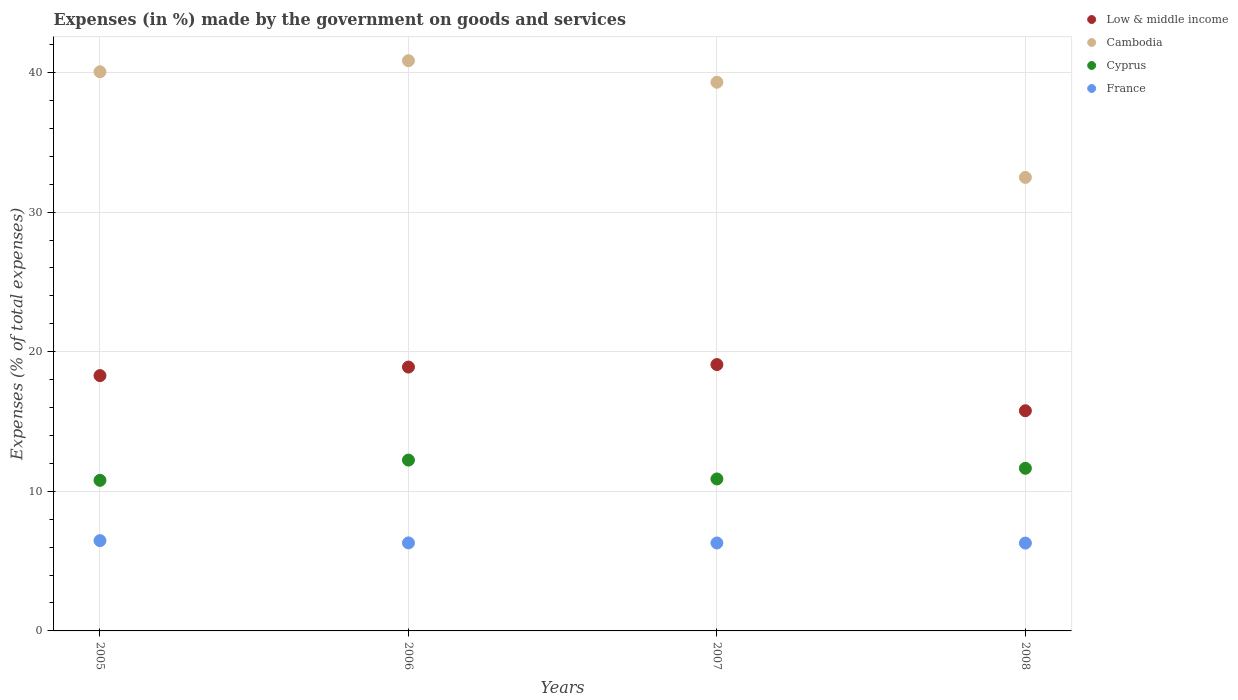How many different coloured dotlines are there?
Offer a very short reply. 4. What is the percentage of expenses made by the government on goods and services in Low & middle income in 2008?
Offer a very short reply. 15.77. Across all years, what is the maximum percentage of expenses made by the government on goods and services in France?
Ensure brevity in your answer.  6.47. Across all years, what is the minimum percentage of expenses made by the government on goods and services in Low & middle income?
Ensure brevity in your answer.  15.77. In which year was the percentage of expenses made by the government on goods and services in Cambodia maximum?
Offer a terse response. 2006. What is the total percentage of expenses made by the government on goods and services in Cambodia in the graph?
Ensure brevity in your answer.  152.67. What is the difference between the percentage of expenses made by the government on goods and services in France in 2005 and that in 2008?
Offer a terse response. 0.17. What is the difference between the percentage of expenses made by the government on goods and services in Low & middle income in 2006 and the percentage of expenses made by the government on goods and services in Cambodia in 2007?
Your answer should be very brief. -20.4. What is the average percentage of expenses made by the government on goods and services in Low & middle income per year?
Ensure brevity in your answer.  18.01. In the year 2007, what is the difference between the percentage of expenses made by the government on goods and services in Cyprus and percentage of expenses made by the government on goods and services in France?
Offer a terse response. 4.59. What is the ratio of the percentage of expenses made by the government on goods and services in France in 2005 to that in 2006?
Provide a succinct answer. 1.03. Is the percentage of expenses made by the government on goods and services in France in 2007 less than that in 2008?
Offer a very short reply. No. What is the difference between the highest and the second highest percentage of expenses made by the government on goods and services in Cyprus?
Provide a succinct answer. 0.59. What is the difference between the highest and the lowest percentage of expenses made by the government on goods and services in Cambodia?
Ensure brevity in your answer.  8.36. Is it the case that in every year, the sum of the percentage of expenses made by the government on goods and services in France and percentage of expenses made by the government on goods and services in Cambodia  is greater than the percentage of expenses made by the government on goods and services in Low & middle income?
Give a very brief answer. Yes. Are the values on the major ticks of Y-axis written in scientific E-notation?
Your answer should be very brief. No. Where does the legend appear in the graph?
Ensure brevity in your answer.  Top right. How many legend labels are there?
Offer a very short reply. 4. What is the title of the graph?
Provide a short and direct response. Expenses (in %) made by the government on goods and services. Does "Moldova" appear as one of the legend labels in the graph?
Offer a terse response. No. What is the label or title of the X-axis?
Your response must be concise. Years. What is the label or title of the Y-axis?
Offer a terse response. Expenses (% of total expenses). What is the Expenses (% of total expenses) in Low & middle income in 2005?
Provide a succinct answer. 18.29. What is the Expenses (% of total expenses) of Cambodia in 2005?
Give a very brief answer. 40.05. What is the Expenses (% of total expenses) in Cyprus in 2005?
Give a very brief answer. 10.79. What is the Expenses (% of total expenses) of France in 2005?
Your answer should be very brief. 6.47. What is the Expenses (% of total expenses) in Low & middle income in 2006?
Keep it short and to the point. 18.9. What is the Expenses (% of total expenses) of Cambodia in 2006?
Offer a very short reply. 40.84. What is the Expenses (% of total expenses) of Cyprus in 2006?
Give a very brief answer. 12.24. What is the Expenses (% of total expenses) in France in 2006?
Your response must be concise. 6.3. What is the Expenses (% of total expenses) of Low & middle income in 2007?
Make the answer very short. 19.08. What is the Expenses (% of total expenses) of Cambodia in 2007?
Offer a very short reply. 39.3. What is the Expenses (% of total expenses) of Cyprus in 2007?
Give a very brief answer. 10.89. What is the Expenses (% of total expenses) in France in 2007?
Offer a terse response. 6.3. What is the Expenses (% of total expenses) of Low & middle income in 2008?
Offer a terse response. 15.77. What is the Expenses (% of total expenses) of Cambodia in 2008?
Provide a short and direct response. 32.48. What is the Expenses (% of total expenses) in Cyprus in 2008?
Your answer should be very brief. 11.65. What is the Expenses (% of total expenses) in France in 2008?
Offer a very short reply. 6.29. Across all years, what is the maximum Expenses (% of total expenses) of Low & middle income?
Provide a succinct answer. 19.08. Across all years, what is the maximum Expenses (% of total expenses) in Cambodia?
Provide a succinct answer. 40.84. Across all years, what is the maximum Expenses (% of total expenses) of Cyprus?
Your answer should be very brief. 12.24. Across all years, what is the maximum Expenses (% of total expenses) of France?
Your answer should be compact. 6.47. Across all years, what is the minimum Expenses (% of total expenses) in Low & middle income?
Your answer should be compact. 15.77. Across all years, what is the minimum Expenses (% of total expenses) in Cambodia?
Your answer should be compact. 32.48. Across all years, what is the minimum Expenses (% of total expenses) in Cyprus?
Your answer should be compact. 10.79. Across all years, what is the minimum Expenses (% of total expenses) of France?
Provide a short and direct response. 6.29. What is the total Expenses (% of total expenses) in Low & middle income in the graph?
Ensure brevity in your answer.  72.04. What is the total Expenses (% of total expenses) in Cambodia in the graph?
Provide a succinct answer. 152.67. What is the total Expenses (% of total expenses) of Cyprus in the graph?
Keep it short and to the point. 45.56. What is the total Expenses (% of total expenses) of France in the graph?
Offer a very short reply. 25.36. What is the difference between the Expenses (% of total expenses) in Low & middle income in 2005 and that in 2006?
Provide a succinct answer. -0.61. What is the difference between the Expenses (% of total expenses) in Cambodia in 2005 and that in 2006?
Your response must be concise. -0.79. What is the difference between the Expenses (% of total expenses) in Cyprus in 2005 and that in 2006?
Ensure brevity in your answer.  -1.45. What is the difference between the Expenses (% of total expenses) of France in 2005 and that in 2006?
Ensure brevity in your answer.  0.16. What is the difference between the Expenses (% of total expenses) of Low & middle income in 2005 and that in 2007?
Offer a terse response. -0.79. What is the difference between the Expenses (% of total expenses) of Cambodia in 2005 and that in 2007?
Provide a short and direct response. 0.75. What is the difference between the Expenses (% of total expenses) of Cyprus in 2005 and that in 2007?
Make the answer very short. -0.1. What is the difference between the Expenses (% of total expenses) of France in 2005 and that in 2007?
Make the answer very short. 0.17. What is the difference between the Expenses (% of total expenses) of Low & middle income in 2005 and that in 2008?
Offer a very short reply. 2.52. What is the difference between the Expenses (% of total expenses) in Cambodia in 2005 and that in 2008?
Offer a very short reply. 7.57. What is the difference between the Expenses (% of total expenses) in Cyprus in 2005 and that in 2008?
Ensure brevity in your answer.  -0.86. What is the difference between the Expenses (% of total expenses) in France in 2005 and that in 2008?
Provide a short and direct response. 0.17. What is the difference between the Expenses (% of total expenses) in Low & middle income in 2006 and that in 2007?
Your response must be concise. -0.18. What is the difference between the Expenses (% of total expenses) of Cambodia in 2006 and that in 2007?
Ensure brevity in your answer.  1.54. What is the difference between the Expenses (% of total expenses) in Cyprus in 2006 and that in 2007?
Your answer should be very brief. 1.35. What is the difference between the Expenses (% of total expenses) in France in 2006 and that in 2007?
Give a very brief answer. 0.01. What is the difference between the Expenses (% of total expenses) of Low & middle income in 2006 and that in 2008?
Your answer should be very brief. 3.13. What is the difference between the Expenses (% of total expenses) of Cambodia in 2006 and that in 2008?
Give a very brief answer. 8.36. What is the difference between the Expenses (% of total expenses) in Cyprus in 2006 and that in 2008?
Provide a succinct answer. 0.59. What is the difference between the Expenses (% of total expenses) of France in 2006 and that in 2008?
Offer a very short reply. 0.01. What is the difference between the Expenses (% of total expenses) in Low & middle income in 2007 and that in 2008?
Your response must be concise. 3.31. What is the difference between the Expenses (% of total expenses) in Cambodia in 2007 and that in 2008?
Offer a very short reply. 6.82. What is the difference between the Expenses (% of total expenses) in Cyprus in 2007 and that in 2008?
Offer a terse response. -0.76. What is the difference between the Expenses (% of total expenses) in France in 2007 and that in 2008?
Ensure brevity in your answer.  0.01. What is the difference between the Expenses (% of total expenses) in Low & middle income in 2005 and the Expenses (% of total expenses) in Cambodia in 2006?
Your response must be concise. -22.56. What is the difference between the Expenses (% of total expenses) of Low & middle income in 2005 and the Expenses (% of total expenses) of Cyprus in 2006?
Make the answer very short. 6.05. What is the difference between the Expenses (% of total expenses) in Low & middle income in 2005 and the Expenses (% of total expenses) in France in 2006?
Provide a short and direct response. 11.98. What is the difference between the Expenses (% of total expenses) in Cambodia in 2005 and the Expenses (% of total expenses) in Cyprus in 2006?
Offer a very short reply. 27.81. What is the difference between the Expenses (% of total expenses) in Cambodia in 2005 and the Expenses (% of total expenses) in France in 2006?
Make the answer very short. 33.74. What is the difference between the Expenses (% of total expenses) of Cyprus in 2005 and the Expenses (% of total expenses) of France in 2006?
Ensure brevity in your answer.  4.48. What is the difference between the Expenses (% of total expenses) of Low & middle income in 2005 and the Expenses (% of total expenses) of Cambodia in 2007?
Keep it short and to the point. -21.01. What is the difference between the Expenses (% of total expenses) in Low & middle income in 2005 and the Expenses (% of total expenses) in Cyprus in 2007?
Ensure brevity in your answer.  7.4. What is the difference between the Expenses (% of total expenses) of Low & middle income in 2005 and the Expenses (% of total expenses) of France in 2007?
Keep it short and to the point. 11.99. What is the difference between the Expenses (% of total expenses) in Cambodia in 2005 and the Expenses (% of total expenses) in Cyprus in 2007?
Your answer should be compact. 29.16. What is the difference between the Expenses (% of total expenses) of Cambodia in 2005 and the Expenses (% of total expenses) of France in 2007?
Provide a succinct answer. 33.75. What is the difference between the Expenses (% of total expenses) in Cyprus in 2005 and the Expenses (% of total expenses) in France in 2007?
Your answer should be very brief. 4.49. What is the difference between the Expenses (% of total expenses) in Low & middle income in 2005 and the Expenses (% of total expenses) in Cambodia in 2008?
Provide a succinct answer. -14.2. What is the difference between the Expenses (% of total expenses) in Low & middle income in 2005 and the Expenses (% of total expenses) in Cyprus in 2008?
Offer a terse response. 6.64. What is the difference between the Expenses (% of total expenses) of Low & middle income in 2005 and the Expenses (% of total expenses) of France in 2008?
Give a very brief answer. 11.99. What is the difference between the Expenses (% of total expenses) of Cambodia in 2005 and the Expenses (% of total expenses) of Cyprus in 2008?
Provide a short and direct response. 28.4. What is the difference between the Expenses (% of total expenses) of Cambodia in 2005 and the Expenses (% of total expenses) of France in 2008?
Give a very brief answer. 33.76. What is the difference between the Expenses (% of total expenses) of Cyprus in 2005 and the Expenses (% of total expenses) of France in 2008?
Offer a very short reply. 4.49. What is the difference between the Expenses (% of total expenses) of Low & middle income in 2006 and the Expenses (% of total expenses) of Cambodia in 2007?
Make the answer very short. -20.4. What is the difference between the Expenses (% of total expenses) in Low & middle income in 2006 and the Expenses (% of total expenses) in Cyprus in 2007?
Make the answer very short. 8.01. What is the difference between the Expenses (% of total expenses) of Low & middle income in 2006 and the Expenses (% of total expenses) of France in 2007?
Your response must be concise. 12.6. What is the difference between the Expenses (% of total expenses) in Cambodia in 2006 and the Expenses (% of total expenses) in Cyprus in 2007?
Your answer should be very brief. 29.96. What is the difference between the Expenses (% of total expenses) in Cambodia in 2006 and the Expenses (% of total expenses) in France in 2007?
Give a very brief answer. 34.54. What is the difference between the Expenses (% of total expenses) in Cyprus in 2006 and the Expenses (% of total expenses) in France in 2007?
Your response must be concise. 5.94. What is the difference between the Expenses (% of total expenses) of Low & middle income in 2006 and the Expenses (% of total expenses) of Cambodia in 2008?
Keep it short and to the point. -13.58. What is the difference between the Expenses (% of total expenses) of Low & middle income in 2006 and the Expenses (% of total expenses) of Cyprus in 2008?
Make the answer very short. 7.25. What is the difference between the Expenses (% of total expenses) in Low & middle income in 2006 and the Expenses (% of total expenses) in France in 2008?
Provide a short and direct response. 12.61. What is the difference between the Expenses (% of total expenses) of Cambodia in 2006 and the Expenses (% of total expenses) of Cyprus in 2008?
Provide a short and direct response. 29.2. What is the difference between the Expenses (% of total expenses) in Cambodia in 2006 and the Expenses (% of total expenses) in France in 2008?
Ensure brevity in your answer.  34.55. What is the difference between the Expenses (% of total expenses) of Cyprus in 2006 and the Expenses (% of total expenses) of France in 2008?
Keep it short and to the point. 5.94. What is the difference between the Expenses (% of total expenses) of Low & middle income in 2007 and the Expenses (% of total expenses) of Cambodia in 2008?
Your response must be concise. -13.4. What is the difference between the Expenses (% of total expenses) in Low & middle income in 2007 and the Expenses (% of total expenses) in Cyprus in 2008?
Offer a terse response. 7.43. What is the difference between the Expenses (% of total expenses) in Low & middle income in 2007 and the Expenses (% of total expenses) in France in 2008?
Your answer should be compact. 12.79. What is the difference between the Expenses (% of total expenses) in Cambodia in 2007 and the Expenses (% of total expenses) in Cyprus in 2008?
Offer a very short reply. 27.65. What is the difference between the Expenses (% of total expenses) of Cambodia in 2007 and the Expenses (% of total expenses) of France in 2008?
Your response must be concise. 33.01. What is the difference between the Expenses (% of total expenses) in Cyprus in 2007 and the Expenses (% of total expenses) in France in 2008?
Give a very brief answer. 4.59. What is the average Expenses (% of total expenses) in Low & middle income per year?
Offer a very short reply. 18.01. What is the average Expenses (% of total expenses) of Cambodia per year?
Provide a short and direct response. 38.17. What is the average Expenses (% of total expenses) of Cyprus per year?
Make the answer very short. 11.39. What is the average Expenses (% of total expenses) in France per year?
Make the answer very short. 6.34. In the year 2005, what is the difference between the Expenses (% of total expenses) of Low & middle income and Expenses (% of total expenses) of Cambodia?
Offer a terse response. -21.76. In the year 2005, what is the difference between the Expenses (% of total expenses) of Low & middle income and Expenses (% of total expenses) of Cyprus?
Make the answer very short. 7.5. In the year 2005, what is the difference between the Expenses (% of total expenses) of Low & middle income and Expenses (% of total expenses) of France?
Offer a very short reply. 11.82. In the year 2005, what is the difference between the Expenses (% of total expenses) in Cambodia and Expenses (% of total expenses) in Cyprus?
Your response must be concise. 29.26. In the year 2005, what is the difference between the Expenses (% of total expenses) in Cambodia and Expenses (% of total expenses) in France?
Provide a succinct answer. 33.58. In the year 2005, what is the difference between the Expenses (% of total expenses) of Cyprus and Expenses (% of total expenses) of France?
Your response must be concise. 4.32. In the year 2006, what is the difference between the Expenses (% of total expenses) of Low & middle income and Expenses (% of total expenses) of Cambodia?
Give a very brief answer. -21.94. In the year 2006, what is the difference between the Expenses (% of total expenses) in Low & middle income and Expenses (% of total expenses) in Cyprus?
Offer a very short reply. 6.66. In the year 2006, what is the difference between the Expenses (% of total expenses) of Low & middle income and Expenses (% of total expenses) of France?
Offer a terse response. 12.6. In the year 2006, what is the difference between the Expenses (% of total expenses) in Cambodia and Expenses (% of total expenses) in Cyprus?
Ensure brevity in your answer.  28.61. In the year 2006, what is the difference between the Expenses (% of total expenses) in Cambodia and Expenses (% of total expenses) in France?
Make the answer very short. 34.54. In the year 2006, what is the difference between the Expenses (% of total expenses) of Cyprus and Expenses (% of total expenses) of France?
Provide a short and direct response. 5.93. In the year 2007, what is the difference between the Expenses (% of total expenses) in Low & middle income and Expenses (% of total expenses) in Cambodia?
Your answer should be very brief. -20.22. In the year 2007, what is the difference between the Expenses (% of total expenses) of Low & middle income and Expenses (% of total expenses) of Cyprus?
Keep it short and to the point. 8.19. In the year 2007, what is the difference between the Expenses (% of total expenses) in Low & middle income and Expenses (% of total expenses) in France?
Your response must be concise. 12.78. In the year 2007, what is the difference between the Expenses (% of total expenses) in Cambodia and Expenses (% of total expenses) in Cyprus?
Your answer should be very brief. 28.41. In the year 2007, what is the difference between the Expenses (% of total expenses) of Cambodia and Expenses (% of total expenses) of France?
Offer a very short reply. 33. In the year 2007, what is the difference between the Expenses (% of total expenses) in Cyprus and Expenses (% of total expenses) in France?
Make the answer very short. 4.59. In the year 2008, what is the difference between the Expenses (% of total expenses) in Low & middle income and Expenses (% of total expenses) in Cambodia?
Offer a very short reply. -16.71. In the year 2008, what is the difference between the Expenses (% of total expenses) in Low & middle income and Expenses (% of total expenses) in Cyprus?
Provide a short and direct response. 4.12. In the year 2008, what is the difference between the Expenses (% of total expenses) of Low & middle income and Expenses (% of total expenses) of France?
Your answer should be very brief. 9.48. In the year 2008, what is the difference between the Expenses (% of total expenses) in Cambodia and Expenses (% of total expenses) in Cyprus?
Offer a terse response. 20.83. In the year 2008, what is the difference between the Expenses (% of total expenses) of Cambodia and Expenses (% of total expenses) of France?
Ensure brevity in your answer.  26.19. In the year 2008, what is the difference between the Expenses (% of total expenses) of Cyprus and Expenses (% of total expenses) of France?
Offer a terse response. 5.36. What is the ratio of the Expenses (% of total expenses) in Low & middle income in 2005 to that in 2006?
Provide a succinct answer. 0.97. What is the ratio of the Expenses (% of total expenses) in Cambodia in 2005 to that in 2006?
Make the answer very short. 0.98. What is the ratio of the Expenses (% of total expenses) in Cyprus in 2005 to that in 2006?
Offer a terse response. 0.88. What is the ratio of the Expenses (% of total expenses) of France in 2005 to that in 2006?
Offer a terse response. 1.03. What is the ratio of the Expenses (% of total expenses) in Low & middle income in 2005 to that in 2007?
Offer a terse response. 0.96. What is the ratio of the Expenses (% of total expenses) in Cambodia in 2005 to that in 2007?
Give a very brief answer. 1.02. What is the ratio of the Expenses (% of total expenses) in Cyprus in 2005 to that in 2007?
Offer a very short reply. 0.99. What is the ratio of the Expenses (% of total expenses) in France in 2005 to that in 2007?
Make the answer very short. 1.03. What is the ratio of the Expenses (% of total expenses) of Low & middle income in 2005 to that in 2008?
Your answer should be compact. 1.16. What is the ratio of the Expenses (% of total expenses) of Cambodia in 2005 to that in 2008?
Your response must be concise. 1.23. What is the ratio of the Expenses (% of total expenses) in Cyprus in 2005 to that in 2008?
Offer a very short reply. 0.93. What is the ratio of the Expenses (% of total expenses) in France in 2005 to that in 2008?
Provide a short and direct response. 1.03. What is the ratio of the Expenses (% of total expenses) of Cambodia in 2006 to that in 2007?
Provide a succinct answer. 1.04. What is the ratio of the Expenses (% of total expenses) of Cyprus in 2006 to that in 2007?
Your answer should be compact. 1.12. What is the ratio of the Expenses (% of total expenses) of France in 2006 to that in 2007?
Make the answer very short. 1. What is the ratio of the Expenses (% of total expenses) in Low & middle income in 2006 to that in 2008?
Your response must be concise. 1.2. What is the ratio of the Expenses (% of total expenses) in Cambodia in 2006 to that in 2008?
Provide a succinct answer. 1.26. What is the ratio of the Expenses (% of total expenses) of Cyprus in 2006 to that in 2008?
Your answer should be compact. 1.05. What is the ratio of the Expenses (% of total expenses) in Low & middle income in 2007 to that in 2008?
Provide a succinct answer. 1.21. What is the ratio of the Expenses (% of total expenses) in Cambodia in 2007 to that in 2008?
Make the answer very short. 1.21. What is the ratio of the Expenses (% of total expenses) of Cyprus in 2007 to that in 2008?
Your answer should be compact. 0.93. What is the ratio of the Expenses (% of total expenses) of France in 2007 to that in 2008?
Offer a very short reply. 1. What is the difference between the highest and the second highest Expenses (% of total expenses) in Low & middle income?
Provide a short and direct response. 0.18. What is the difference between the highest and the second highest Expenses (% of total expenses) in Cambodia?
Your answer should be compact. 0.79. What is the difference between the highest and the second highest Expenses (% of total expenses) in Cyprus?
Provide a short and direct response. 0.59. What is the difference between the highest and the second highest Expenses (% of total expenses) of France?
Give a very brief answer. 0.16. What is the difference between the highest and the lowest Expenses (% of total expenses) in Low & middle income?
Ensure brevity in your answer.  3.31. What is the difference between the highest and the lowest Expenses (% of total expenses) of Cambodia?
Offer a terse response. 8.36. What is the difference between the highest and the lowest Expenses (% of total expenses) in Cyprus?
Provide a short and direct response. 1.45. What is the difference between the highest and the lowest Expenses (% of total expenses) in France?
Offer a very short reply. 0.17. 